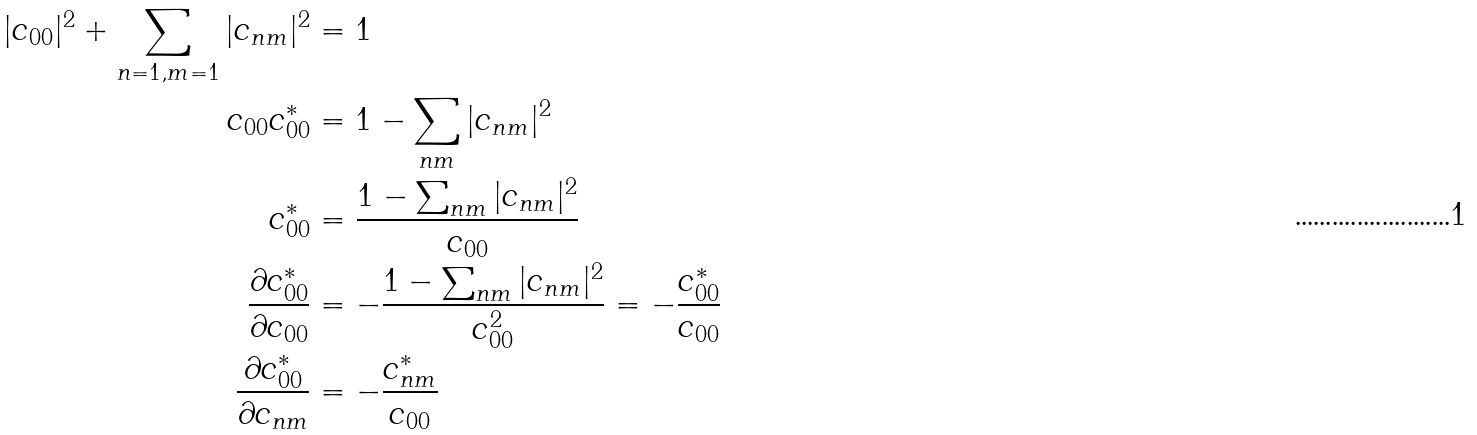<formula> <loc_0><loc_0><loc_500><loc_500>| c _ { 0 0 } | ^ { 2 } + \sum _ { n = 1 , m = 1 } | c _ { n m } | ^ { 2 } & = 1 \\ c _ { 0 0 } c _ { 0 0 } ^ { * } & = 1 - \sum _ { n m } | c _ { n m } | ^ { 2 } \\ c _ { 0 0 } ^ { * } & = \frac { 1 - \sum _ { n m } | c _ { n m } | ^ { 2 } } { c _ { 0 0 } } \\ \frac { \partial c _ { 0 0 } ^ { * } } { \partial c _ { 0 0 } } & = - \frac { 1 - \sum _ { n m } | c _ { n m } | ^ { 2 } } { c _ { 0 0 } ^ { 2 } } = - \frac { c _ { 0 0 } ^ { * } } { c _ { 0 0 } } \\ \frac { \partial c _ { 0 0 } ^ { * } } { \partial c _ { n m } } & = - \frac { c _ { n m } ^ { * } } { c _ { 0 0 } } \\</formula> 